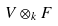<formula> <loc_0><loc_0><loc_500><loc_500>V \otimes _ { k } F</formula> 